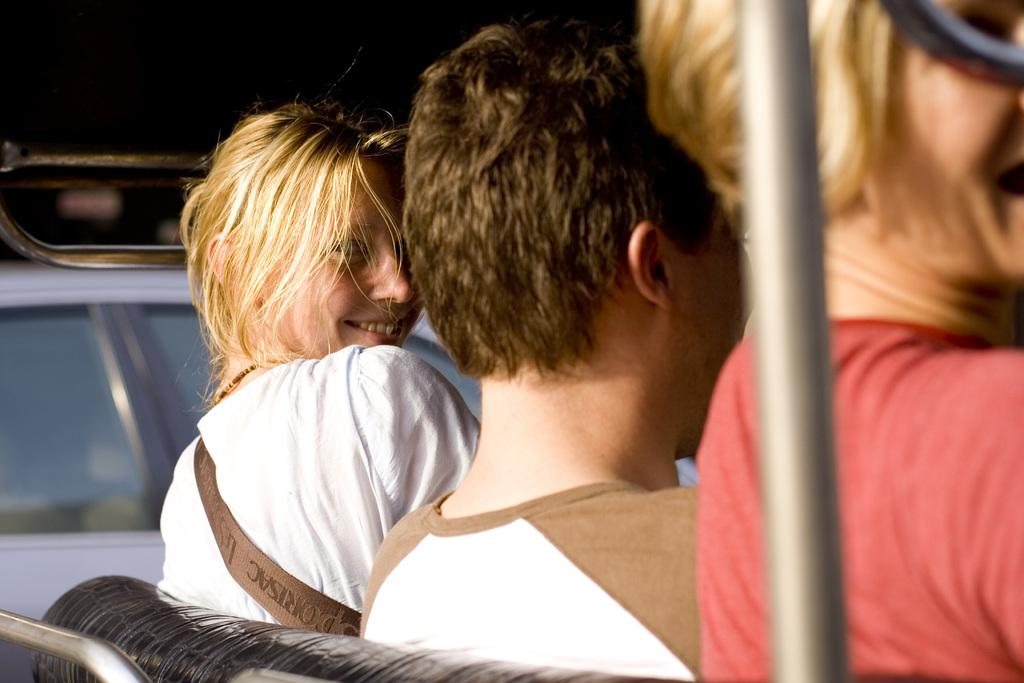What are the people in the image doing? There are people sitting on a bench in the image. How many men and women are in the image? There is one man and two women in the image. Can you describe the facial expression of one of the women? One of the women is smiling. What can be seen on the right side of the image? There is a pole on the right side of the image. What type of apparel is the man wearing to cover his loss in the image? There is no indication of loss or any specific apparel in the image; the man is simply sitting on a bench with the other people. 